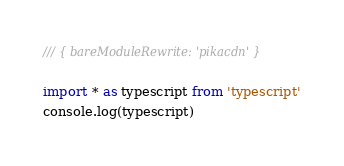<code> <loc_0><loc_0><loc_500><loc_500><_TypeScript_>/// { bareModuleRewrite: 'pikacdn' }

import * as typescript from 'typescript'
console.log(typescript)
</code> 